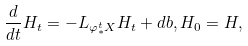<formula> <loc_0><loc_0><loc_500><loc_500>\frac { d } { d t } H _ { t } = - L _ { \varphi ^ { t } _ { * } X } H _ { t } + d b , H _ { 0 } = H ,</formula> 